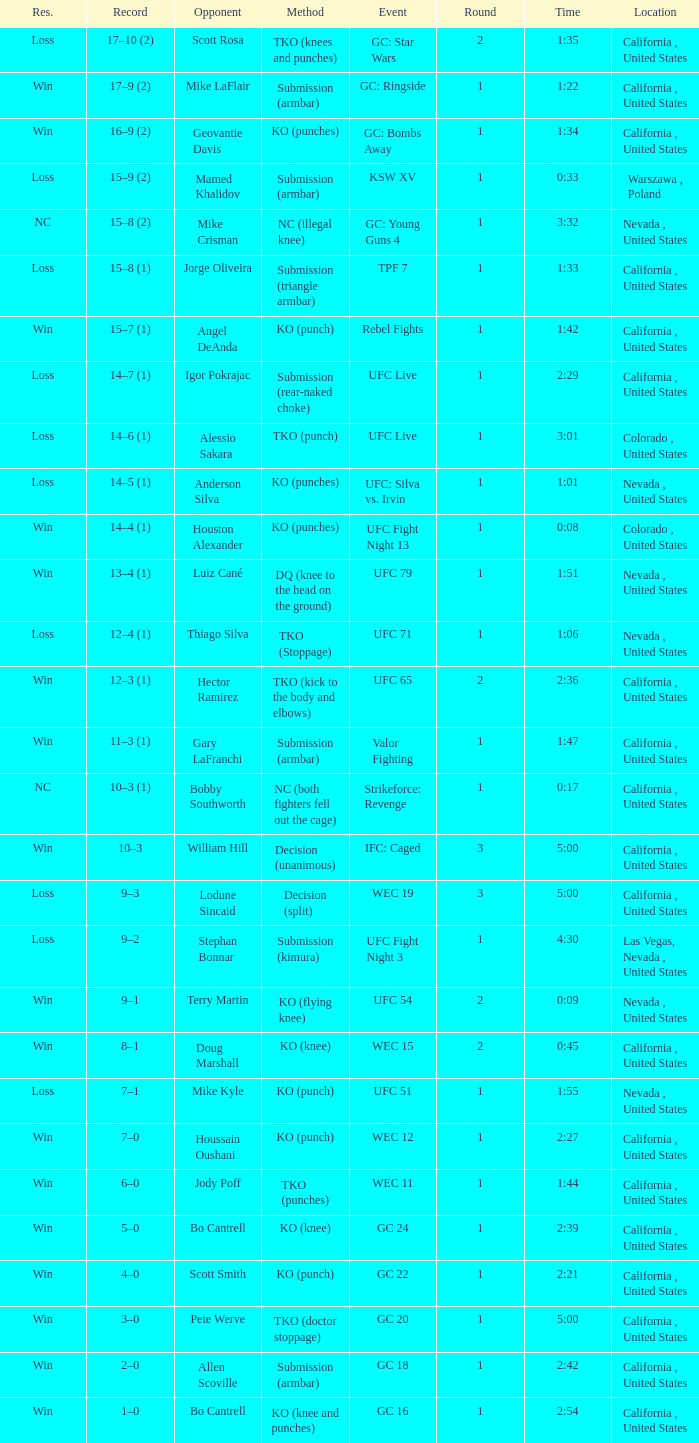What was the method when the time was 1:01? KO (punches). 